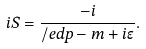<formula> <loc_0><loc_0><loc_500><loc_500>i S = \frac { - i } { \slash e d p - m + i \epsilon } .</formula> 